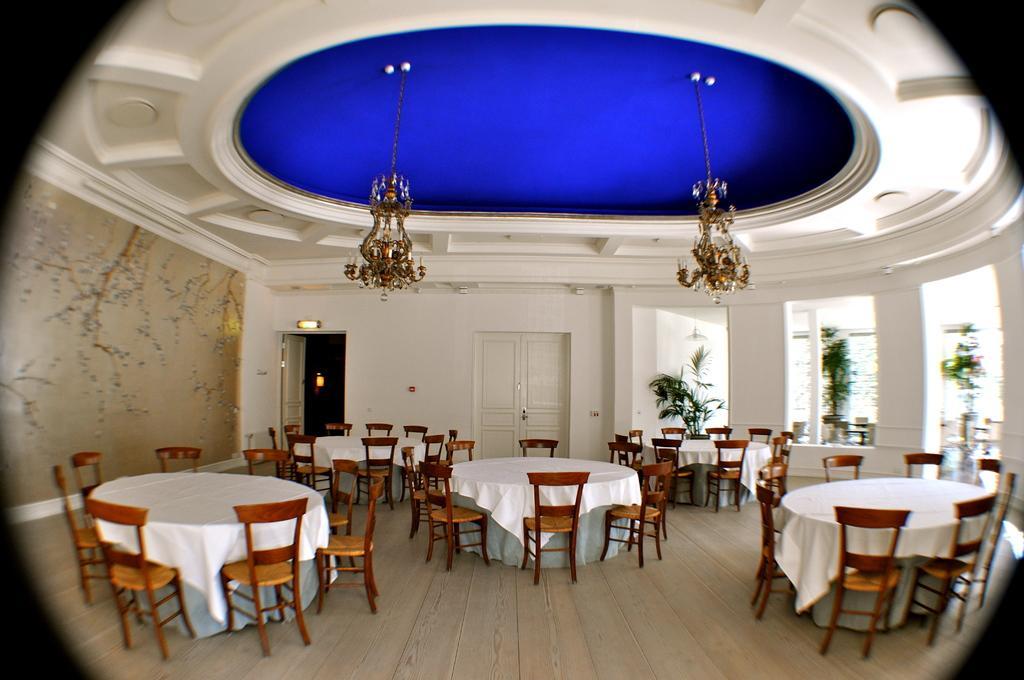Can you describe this image briefly? It is an inside view of the dining hall. Here we can see so many chairs, tables with cloth on the floor. Background there is a wall, doors, few plants. Top of the image, there is a ceiling with chandeliers. 